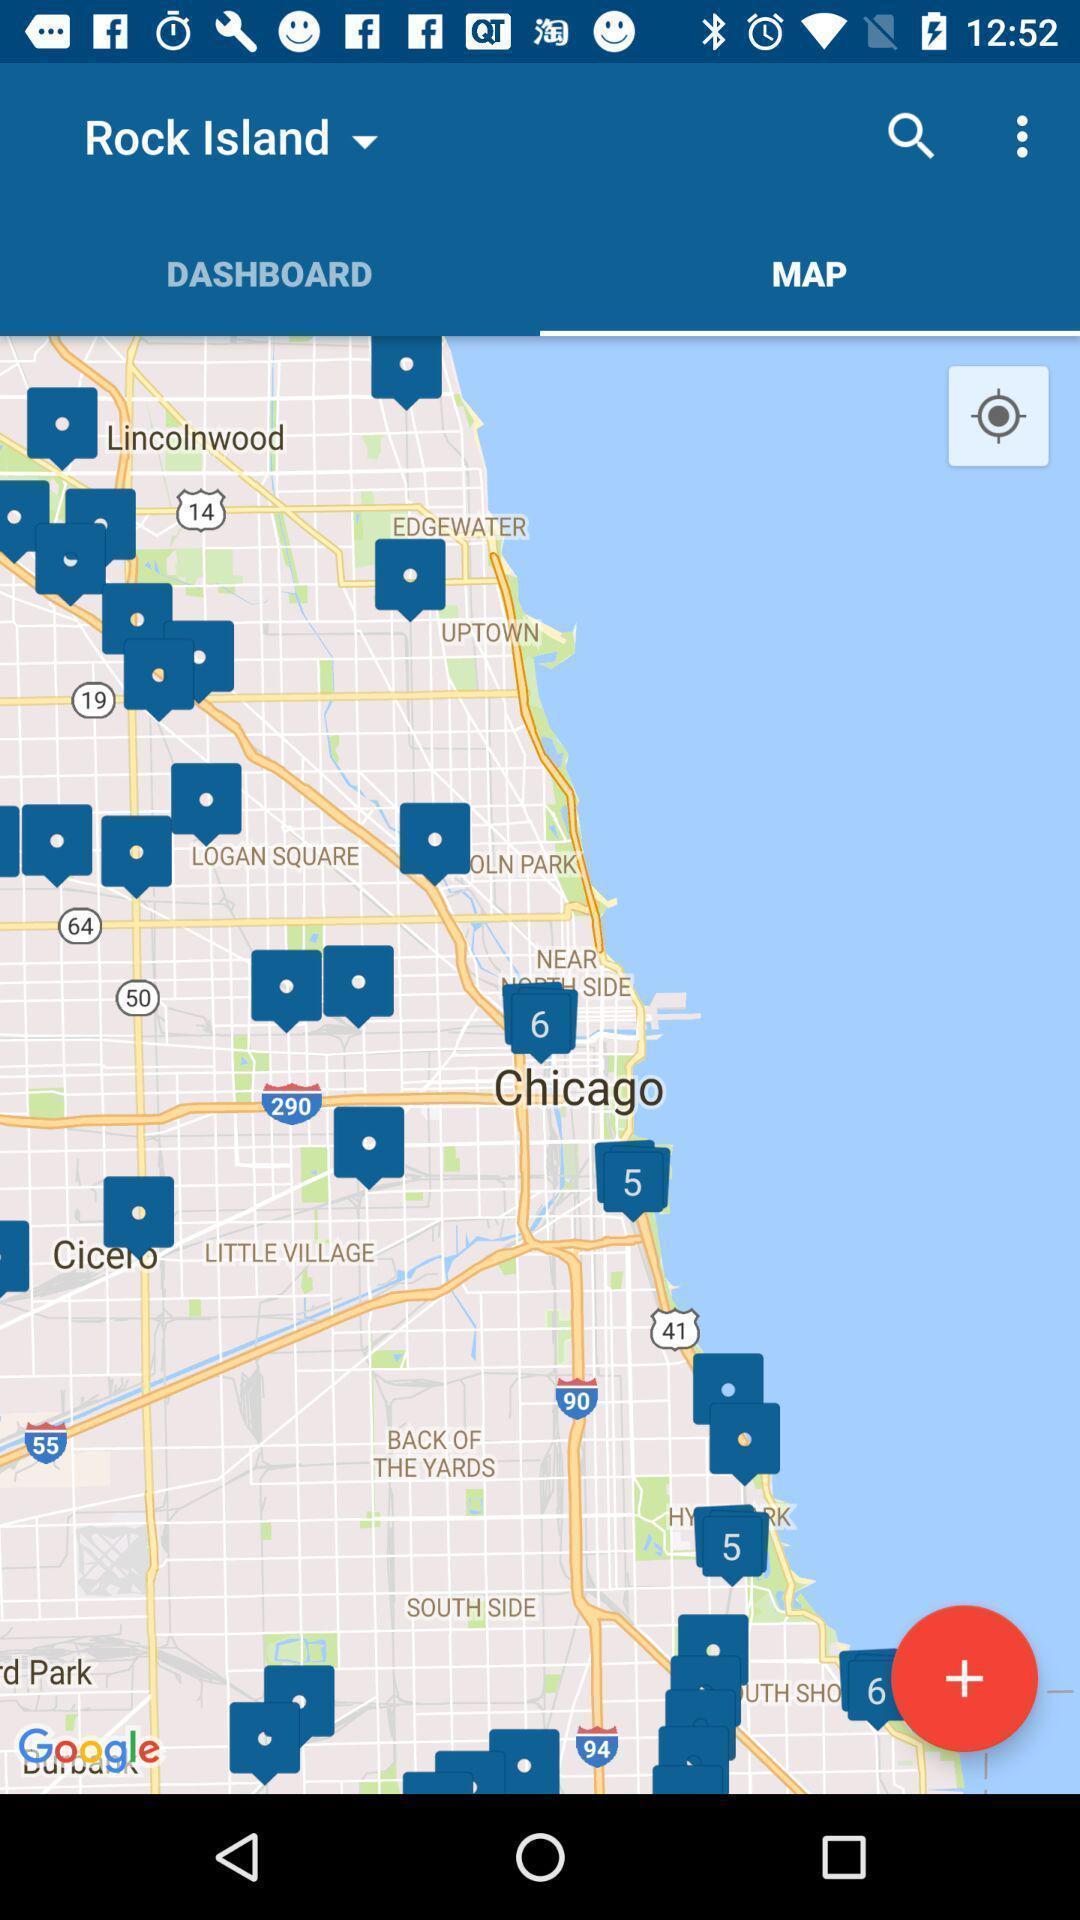Explain the elements present in this screenshot. Page showing search bar to find location. 